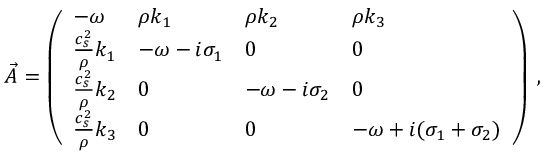<formula> <loc_0><loc_0><loc_500><loc_500>\vec { A } = \left ( \begin{array} { l l l l } { - { \omega } } & { \rho k _ { 1 } } & { \rho k _ { 2 } } & { \rho k _ { 3 } } \\ { \frac { c _ { s } ^ { 2 } } { \rho } k _ { 1 } } & { - { \omega } - i \sigma _ { 1 } } & { 0 } & { 0 } \\ { \frac { c _ { s } ^ { 2 } } { \rho } k _ { 2 } } & { 0 } & { - { \omega } - i \sigma _ { 2 } } & { 0 } \\ { \frac { c _ { s } ^ { 2 } } { \rho } k _ { 3 } } & { 0 } & { 0 } & { - { \omega } + i ( \sigma _ { 1 } + \sigma _ { 2 } ) } \end{array} \right ) \, ,</formula> 